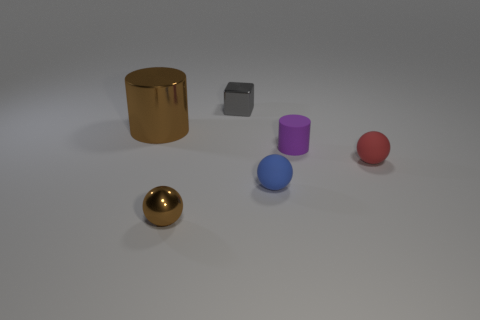There is a brown object to the left of the tiny metal object that is in front of the blue rubber object; is there a thing in front of it?
Keep it short and to the point. Yes. What is the color of the cylinder that is the same material as the brown ball?
Offer a terse response. Brown. Does the shiny object in front of the blue matte sphere have the same color as the large cylinder?
Give a very brief answer. Yes. How many balls are gray metallic things or small rubber things?
Your response must be concise. 2. There is a blue rubber sphere to the right of the object that is in front of the tiny blue matte sphere right of the gray shiny block; how big is it?
Provide a succinct answer. Small. There is a shiny object that is the same size as the gray cube; what shape is it?
Provide a short and direct response. Sphere. The purple object is what shape?
Ensure brevity in your answer.  Cylinder. Are the cylinder right of the brown sphere and the tiny blue object made of the same material?
Keep it short and to the point. Yes. There is a cylinder on the left side of the cylinder that is on the right side of the metal ball; how big is it?
Offer a very short reply. Large. What is the color of the tiny thing that is both to the left of the tiny blue rubber thing and in front of the brown metallic cylinder?
Your answer should be compact. Brown. 